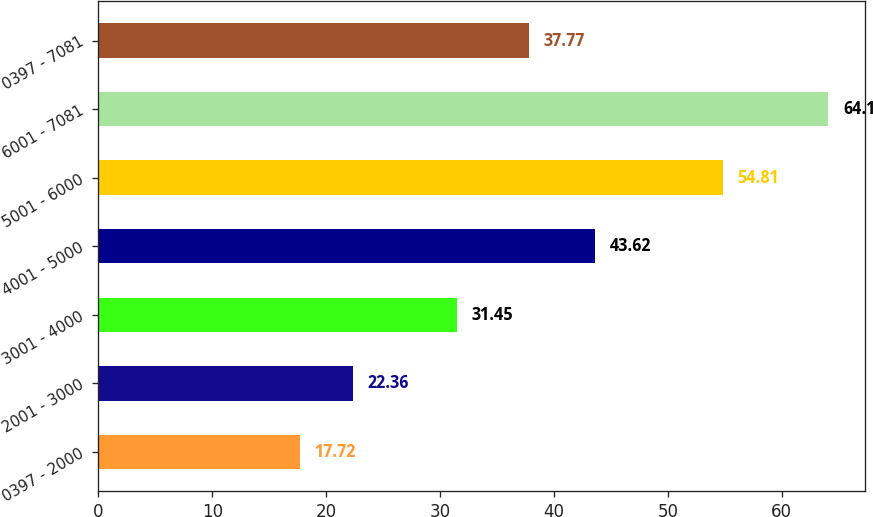Convert chart to OTSL. <chart><loc_0><loc_0><loc_500><loc_500><bar_chart><fcel>0397 - 2000<fcel>2001 - 3000<fcel>3001 - 4000<fcel>4001 - 5000<fcel>5001 - 6000<fcel>6001 - 7081<fcel>0397 - 7081<nl><fcel>17.72<fcel>22.36<fcel>31.45<fcel>43.62<fcel>54.81<fcel>64.1<fcel>37.77<nl></chart> 